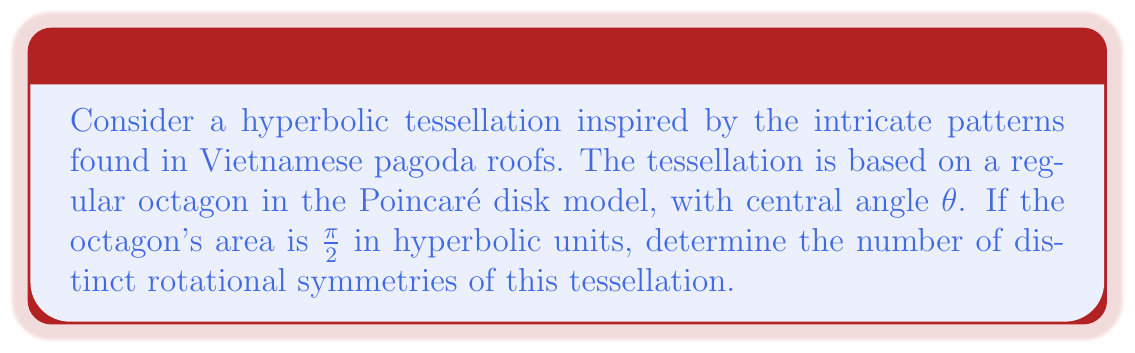Give your solution to this math problem. 1) In hyperbolic geometry, the area of a regular n-gon with central angle $\theta$ is given by:

   $A = (n-2)\pi - n\theta$

2) For our octagon (n = 8) with area $\frac{\pi}{2}$, we have:

   $\frac{\pi}{2} = (8-2)\pi - 8\theta$
   $\frac{\pi}{2} = 6\pi - 8\theta$

3) Solve for $\theta$:

   $8\theta = 6\pi - \frac{\pi}{2} = \frac{11\pi}{2}$
   $\theta = \frac{11\pi}{16}$

4) In hyperbolic geometry, the sum of angles in an octagon is less than $6\pi$. The interior angle of our octagon is:

   $\alpha = \frac{\pi(n-2)}{n} - \theta = \frac{3\pi}{4} - \frac{11\pi}{16} = \frac{\pi}{16}$

5) The rotational symmetries of the tessellation correspond to the rotational symmetries of the octagon. An octagon has 8 rotational symmetries:
   - Identity rotation (0°)
   - Rotations by 45°, 90°, 135°, 180°, 225°, 270°, and 315°

Therefore, there are 8 distinct rotational symmetries in this hyperbolic tessellation.
Answer: 8 